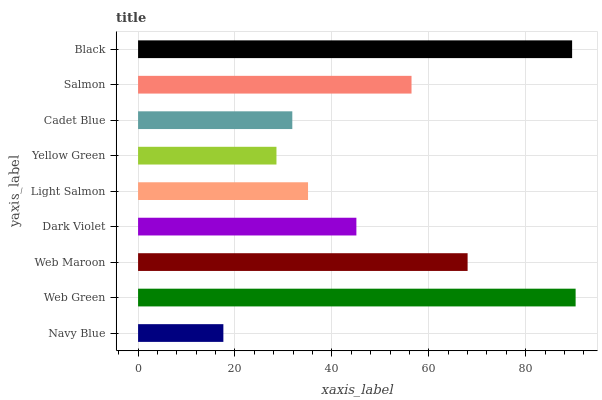Is Navy Blue the minimum?
Answer yes or no. Yes. Is Web Green the maximum?
Answer yes or no. Yes. Is Web Maroon the minimum?
Answer yes or no. No. Is Web Maroon the maximum?
Answer yes or no. No. Is Web Green greater than Web Maroon?
Answer yes or no. Yes. Is Web Maroon less than Web Green?
Answer yes or no. Yes. Is Web Maroon greater than Web Green?
Answer yes or no. No. Is Web Green less than Web Maroon?
Answer yes or no. No. Is Dark Violet the high median?
Answer yes or no. Yes. Is Dark Violet the low median?
Answer yes or no. Yes. Is Yellow Green the high median?
Answer yes or no. No. Is Cadet Blue the low median?
Answer yes or no. No. 